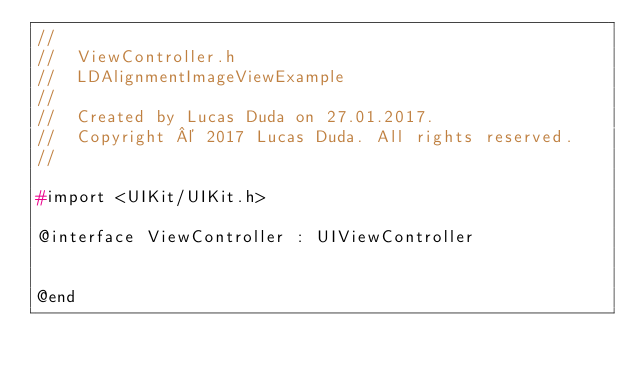Convert code to text. <code><loc_0><loc_0><loc_500><loc_500><_C_>//
//  ViewController.h
//  LDAlignmentImageViewExample
//
//  Created by Lucas Duda on 27.01.2017.
//  Copyright © 2017 Lucas Duda. All rights reserved.
//

#import <UIKit/UIKit.h>

@interface ViewController : UIViewController


@end

</code> 